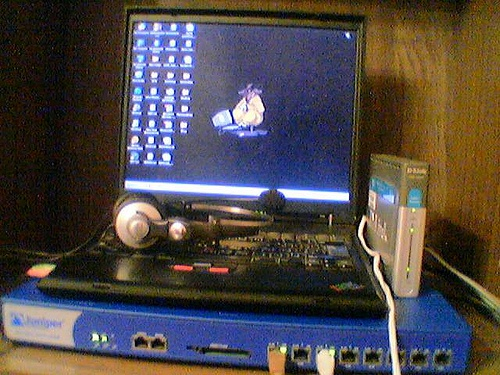Describe the objects in this image and their specific colors. I can see laptop in black, gray, navy, and blue tones and keyboard in black, darkgreen, and gray tones in this image. 